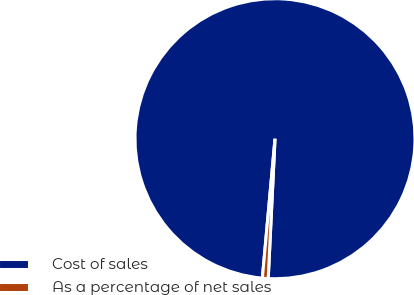<chart> <loc_0><loc_0><loc_500><loc_500><pie_chart><fcel>Cost of sales<fcel>As a percentage of net sales<nl><fcel>99.33%<fcel>0.67%<nl></chart> 